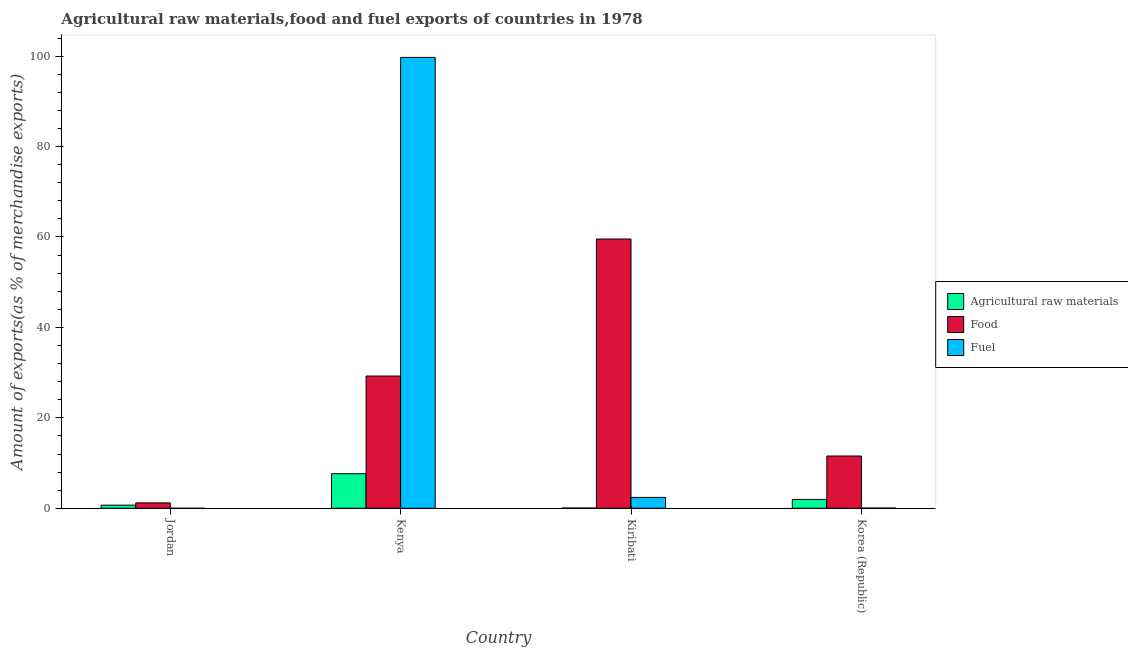How many different coloured bars are there?
Your answer should be very brief. 3. Are the number of bars on each tick of the X-axis equal?
Offer a very short reply. Yes. How many bars are there on the 3rd tick from the left?
Make the answer very short. 3. What is the label of the 2nd group of bars from the left?
Make the answer very short. Kenya. In how many cases, is the number of bars for a given country not equal to the number of legend labels?
Keep it short and to the point. 0. What is the percentage of raw materials exports in Jordan?
Make the answer very short. 0.69. Across all countries, what is the maximum percentage of food exports?
Your answer should be very brief. 59.55. Across all countries, what is the minimum percentage of fuel exports?
Your response must be concise. 0.01. In which country was the percentage of food exports maximum?
Keep it short and to the point. Kiribati. In which country was the percentage of food exports minimum?
Keep it short and to the point. Jordan. What is the total percentage of raw materials exports in the graph?
Make the answer very short. 10.35. What is the difference between the percentage of raw materials exports in Kenya and that in Kiribati?
Ensure brevity in your answer.  7.59. What is the difference between the percentage of food exports in Kenya and the percentage of raw materials exports in Korea (Republic)?
Keep it short and to the point. 27.29. What is the average percentage of raw materials exports per country?
Keep it short and to the point. 2.59. What is the difference between the percentage of fuel exports and percentage of food exports in Korea (Republic)?
Provide a succinct answer. -11.52. In how many countries, is the percentage of fuel exports greater than 36 %?
Provide a succinct answer. 1. What is the ratio of the percentage of fuel exports in Jordan to that in Kiribati?
Your answer should be compact. 0. What is the difference between the highest and the second highest percentage of food exports?
Provide a succinct answer. 30.3. What is the difference between the highest and the lowest percentage of food exports?
Offer a terse response. 58.36. In how many countries, is the percentage of food exports greater than the average percentage of food exports taken over all countries?
Provide a short and direct response. 2. What does the 2nd bar from the left in Kenya represents?
Provide a short and direct response. Food. What does the 1st bar from the right in Kenya represents?
Offer a terse response. Fuel. Is it the case that in every country, the sum of the percentage of raw materials exports and percentage of food exports is greater than the percentage of fuel exports?
Make the answer very short. No. How many bars are there?
Your response must be concise. 12. Are all the bars in the graph horizontal?
Offer a very short reply. No. How many countries are there in the graph?
Offer a terse response. 4. Are the values on the major ticks of Y-axis written in scientific E-notation?
Your answer should be compact. No. Does the graph contain grids?
Ensure brevity in your answer.  No. What is the title of the graph?
Provide a short and direct response. Agricultural raw materials,food and fuel exports of countries in 1978. What is the label or title of the X-axis?
Offer a very short reply. Country. What is the label or title of the Y-axis?
Provide a short and direct response. Amount of exports(as % of merchandise exports). What is the Amount of exports(as % of merchandise exports) of Agricultural raw materials in Jordan?
Give a very brief answer. 0.69. What is the Amount of exports(as % of merchandise exports) in Food in Jordan?
Make the answer very short. 1.2. What is the Amount of exports(as % of merchandise exports) of Fuel in Jordan?
Your answer should be compact. 0.01. What is the Amount of exports(as % of merchandise exports) in Agricultural raw materials in Kenya?
Keep it short and to the point. 7.65. What is the Amount of exports(as % of merchandise exports) in Food in Kenya?
Provide a succinct answer. 29.25. What is the Amount of exports(as % of merchandise exports) of Fuel in Kenya?
Your response must be concise. 99.72. What is the Amount of exports(as % of merchandise exports) in Agricultural raw materials in Kiribati?
Ensure brevity in your answer.  0.05. What is the Amount of exports(as % of merchandise exports) of Food in Kiribati?
Provide a succinct answer. 59.55. What is the Amount of exports(as % of merchandise exports) in Fuel in Kiribati?
Provide a succinct answer. 2.41. What is the Amount of exports(as % of merchandise exports) in Agricultural raw materials in Korea (Republic)?
Make the answer very short. 1.96. What is the Amount of exports(as % of merchandise exports) in Food in Korea (Republic)?
Provide a short and direct response. 11.56. What is the Amount of exports(as % of merchandise exports) of Fuel in Korea (Republic)?
Offer a very short reply. 0.04. Across all countries, what is the maximum Amount of exports(as % of merchandise exports) in Agricultural raw materials?
Offer a very short reply. 7.65. Across all countries, what is the maximum Amount of exports(as % of merchandise exports) in Food?
Your response must be concise. 59.55. Across all countries, what is the maximum Amount of exports(as % of merchandise exports) in Fuel?
Provide a short and direct response. 99.72. Across all countries, what is the minimum Amount of exports(as % of merchandise exports) of Agricultural raw materials?
Your answer should be very brief. 0.05. Across all countries, what is the minimum Amount of exports(as % of merchandise exports) in Food?
Keep it short and to the point. 1.2. Across all countries, what is the minimum Amount of exports(as % of merchandise exports) of Fuel?
Keep it short and to the point. 0.01. What is the total Amount of exports(as % of merchandise exports) in Agricultural raw materials in the graph?
Ensure brevity in your answer.  10.35. What is the total Amount of exports(as % of merchandise exports) in Food in the graph?
Give a very brief answer. 101.56. What is the total Amount of exports(as % of merchandise exports) of Fuel in the graph?
Keep it short and to the point. 102.18. What is the difference between the Amount of exports(as % of merchandise exports) in Agricultural raw materials in Jordan and that in Kenya?
Ensure brevity in your answer.  -6.96. What is the difference between the Amount of exports(as % of merchandise exports) in Food in Jordan and that in Kenya?
Keep it short and to the point. -28.05. What is the difference between the Amount of exports(as % of merchandise exports) of Fuel in Jordan and that in Kenya?
Give a very brief answer. -99.71. What is the difference between the Amount of exports(as % of merchandise exports) of Agricultural raw materials in Jordan and that in Kiribati?
Offer a very short reply. 0.64. What is the difference between the Amount of exports(as % of merchandise exports) of Food in Jordan and that in Kiribati?
Give a very brief answer. -58.36. What is the difference between the Amount of exports(as % of merchandise exports) in Fuel in Jordan and that in Kiribati?
Your answer should be very brief. -2.4. What is the difference between the Amount of exports(as % of merchandise exports) of Agricultural raw materials in Jordan and that in Korea (Republic)?
Keep it short and to the point. -1.27. What is the difference between the Amount of exports(as % of merchandise exports) in Food in Jordan and that in Korea (Republic)?
Your response must be concise. -10.36. What is the difference between the Amount of exports(as % of merchandise exports) of Fuel in Jordan and that in Korea (Republic)?
Offer a very short reply. -0.03. What is the difference between the Amount of exports(as % of merchandise exports) of Agricultural raw materials in Kenya and that in Kiribati?
Offer a very short reply. 7.59. What is the difference between the Amount of exports(as % of merchandise exports) in Food in Kenya and that in Kiribati?
Your answer should be compact. -30.3. What is the difference between the Amount of exports(as % of merchandise exports) of Fuel in Kenya and that in Kiribati?
Provide a succinct answer. 97.31. What is the difference between the Amount of exports(as % of merchandise exports) of Agricultural raw materials in Kenya and that in Korea (Republic)?
Offer a terse response. 5.69. What is the difference between the Amount of exports(as % of merchandise exports) in Food in Kenya and that in Korea (Republic)?
Your response must be concise. 17.69. What is the difference between the Amount of exports(as % of merchandise exports) in Fuel in Kenya and that in Korea (Republic)?
Your answer should be very brief. 99.68. What is the difference between the Amount of exports(as % of merchandise exports) of Agricultural raw materials in Kiribati and that in Korea (Republic)?
Your answer should be very brief. -1.91. What is the difference between the Amount of exports(as % of merchandise exports) of Food in Kiribati and that in Korea (Republic)?
Offer a terse response. 47.99. What is the difference between the Amount of exports(as % of merchandise exports) of Fuel in Kiribati and that in Korea (Republic)?
Give a very brief answer. 2.37. What is the difference between the Amount of exports(as % of merchandise exports) of Agricultural raw materials in Jordan and the Amount of exports(as % of merchandise exports) of Food in Kenya?
Your answer should be compact. -28.56. What is the difference between the Amount of exports(as % of merchandise exports) in Agricultural raw materials in Jordan and the Amount of exports(as % of merchandise exports) in Fuel in Kenya?
Your response must be concise. -99.03. What is the difference between the Amount of exports(as % of merchandise exports) in Food in Jordan and the Amount of exports(as % of merchandise exports) in Fuel in Kenya?
Keep it short and to the point. -98.52. What is the difference between the Amount of exports(as % of merchandise exports) in Agricultural raw materials in Jordan and the Amount of exports(as % of merchandise exports) in Food in Kiribati?
Make the answer very short. -58.86. What is the difference between the Amount of exports(as % of merchandise exports) of Agricultural raw materials in Jordan and the Amount of exports(as % of merchandise exports) of Fuel in Kiribati?
Keep it short and to the point. -1.72. What is the difference between the Amount of exports(as % of merchandise exports) of Food in Jordan and the Amount of exports(as % of merchandise exports) of Fuel in Kiribati?
Your answer should be very brief. -1.21. What is the difference between the Amount of exports(as % of merchandise exports) in Agricultural raw materials in Jordan and the Amount of exports(as % of merchandise exports) in Food in Korea (Republic)?
Provide a short and direct response. -10.87. What is the difference between the Amount of exports(as % of merchandise exports) of Agricultural raw materials in Jordan and the Amount of exports(as % of merchandise exports) of Fuel in Korea (Republic)?
Offer a terse response. 0.65. What is the difference between the Amount of exports(as % of merchandise exports) of Food in Jordan and the Amount of exports(as % of merchandise exports) of Fuel in Korea (Republic)?
Your answer should be compact. 1.16. What is the difference between the Amount of exports(as % of merchandise exports) of Agricultural raw materials in Kenya and the Amount of exports(as % of merchandise exports) of Food in Kiribati?
Ensure brevity in your answer.  -51.91. What is the difference between the Amount of exports(as % of merchandise exports) of Agricultural raw materials in Kenya and the Amount of exports(as % of merchandise exports) of Fuel in Kiribati?
Offer a terse response. 5.24. What is the difference between the Amount of exports(as % of merchandise exports) of Food in Kenya and the Amount of exports(as % of merchandise exports) of Fuel in Kiribati?
Your response must be concise. 26.84. What is the difference between the Amount of exports(as % of merchandise exports) of Agricultural raw materials in Kenya and the Amount of exports(as % of merchandise exports) of Food in Korea (Republic)?
Your answer should be very brief. -3.91. What is the difference between the Amount of exports(as % of merchandise exports) in Agricultural raw materials in Kenya and the Amount of exports(as % of merchandise exports) in Fuel in Korea (Republic)?
Make the answer very short. 7.6. What is the difference between the Amount of exports(as % of merchandise exports) of Food in Kenya and the Amount of exports(as % of merchandise exports) of Fuel in Korea (Republic)?
Provide a short and direct response. 29.21. What is the difference between the Amount of exports(as % of merchandise exports) in Agricultural raw materials in Kiribati and the Amount of exports(as % of merchandise exports) in Food in Korea (Republic)?
Offer a terse response. -11.51. What is the difference between the Amount of exports(as % of merchandise exports) in Agricultural raw materials in Kiribati and the Amount of exports(as % of merchandise exports) in Fuel in Korea (Republic)?
Offer a terse response. 0.01. What is the difference between the Amount of exports(as % of merchandise exports) in Food in Kiribati and the Amount of exports(as % of merchandise exports) in Fuel in Korea (Republic)?
Provide a short and direct response. 59.51. What is the average Amount of exports(as % of merchandise exports) in Agricultural raw materials per country?
Your response must be concise. 2.59. What is the average Amount of exports(as % of merchandise exports) of Food per country?
Provide a succinct answer. 25.39. What is the average Amount of exports(as % of merchandise exports) of Fuel per country?
Your answer should be compact. 25.54. What is the difference between the Amount of exports(as % of merchandise exports) of Agricultural raw materials and Amount of exports(as % of merchandise exports) of Food in Jordan?
Offer a very short reply. -0.51. What is the difference between the Amount of exports(as % of merchandise exports) of Agricultural raw materials and Amount of exports(as % of merchandise exports) of Fuel in Jordan?
Provide a succinct answer. 0.68. What is the difference between the Amount of exports(as % of merchandise exports) of Food and Amount of exports(as % of merchandise exports) of Fuel in Jordan?
Your response must be concise. 1.19. What is the difference between the Amount of exports(as % of merchandise exports) in Agricultural raw materials and Amount of exports(as % of merchandise exports) in Food in Kenya?
Ensure brevity in your answer.  -21.6. What is the difference between the Amount of exports(as % of merchandise exports) of Agricultural raw materials and Amount of exports(as % of merchandise exports) of Fuel in Kenya?
Ensure brevity in your answer.  -92.07. What is the difference between the Amount of exports(as % of merchandise exports) of Food and Amount of exports(as % of merchandise exports) of Fuel in Kenya?
Give a very brief answer. -70.47. What is the difference between the Amount of exports(as % of merchandise exports) in Agricultural raw materials and Amount of exports(as % of merchandise exports) in Food in Kiribati?
Provide a succinct answer. -59.5. What is the difference between the Amount of exports(as % of merchandise exports) in Agricultural raw materials and Amount of exports(as % of merchandise exports) in Fuel in Kiribati?
Your response must be concise. -2.36. What is the difference between the Amount of exports(as % of merchandise exports) of Food and Amount of exports(as % of merchandise exports) of Fuel in Kiribati?
Make the answer very short. 57.14. What is the difference between the Amount of exports(as % of merchandise exports) of Agricultural raw materials and Amount of exports(as % of merchandise exports) of Food in Korea (Republic)?
Your response must be concise. -9.6. What is the difference between the Amount of exports(as % of merchandise exports) of Agricultural raw materials and Amount of exports(as % of merchandise exports) of Fuel in Korea (Republic)?
Make the answer very short. 1.92. What is the difference between the Amount of exports(as % of merchandise exports) in Food and Amount of exports(as % of merchandise exports) in Fuel in Korea (Republic)?
Your response must be concise. 11.52. What is the ratio of the Amount of exports(as % of merchandise exports) in Agricultural raw materials in Jordan to that in Kenya?
Offer a very short reply. 0.09. What is the ratio of the Amount of exports(as % of merchandise exports) in Food in Jordan to that in Kenya?
Make the answer very short. 0.04. What is the ratio of the Amount of exports(as % of merchandise exports) of Fuel in Jordan to that in Kenya?
Give a very brief answer. 0. What is the ratio of the Amount of exports(as % of merchandise exports) of Agricultural raw materials in Jordan to that in Kiribati?
Offer a very short reply. 12.98. What is the ratio of the Amount of exports(as % of merchandise exports) of Food in Jordan to that in Kiribati?
Your response must be concise. 0.02. What is the ratio of the Amount of exports(as % of merchandise exports) of Fuel in Jordan to that in Kiribati?
Your answer should be compact. 0. What is the ratio of the Amount of exports(as % of merchandise exports) in Agricultural raw materials in Jordan to that in Korea (Republic)?
Offer a very short reply. 0.35. What is the ratio of the Amount of exports(as % of merchandise exports) of Food in Jordan to that in Korea (Republic)?
Keep it short and to the point. 0.1. What is the ratio of the Amount of exports(as % of merchandise exports) in Fuel in Jordan to that in Korea (Republic)?
Provide a succinct answer. 0.16. What is the ratio of the Amount of exports(as % of merchandise exports) of Agricultural raw materials in Kenya to that in Kiribati?
Your answer should be very brief. 144.19. What is the ratio of the Amount of exports(as % of merchandise exports) in Food in Kenya to that in Kiribati?
Your response must be concise. 0.49. What is the ratio of the Amount of exports(as % of merchandise exports) of Fuel in Kenya to that in Kiribati?
Offer a terse response. 41.39. What is the ratio of the Amount of exports(as % of merchandise exports) in Food in Kenya to that in Korea (Republic)?
Provide a short and direct response. 2.53. What is the ratio of the Amount of exports(as % of merchandise exports) in Fuel in Kenya to that in Korea (Republic)?
Your answer should be compact. 2410.18. What is the ratio of the Amount of exports(as % of merchandise exports) of Agricultural raw materials in Kiribati to that in Korea (Republic)?
Ensure brevity in your answer.  0.03. What is the ratio of the Amount of exports(as % of merchandise exports) of Food in Kiribati to that in Korea (Republic)?
Provide a short and direct response. 5.15. What is the ratio of the Amount of exports(as % of merchandise exports) of Fuel in Kiribati to that in Korea (Republic)?
Provide a short and direct response. 58.23. What is the difference between the highest and the second highest Amount of exports(as % of merchandise exports) in Agricultural raw materials?
Give a very brief answer. 5.69. What is the difference between the highest and the second highest Amount of exports(as % of merchandise exports) in Food?
Your response must be concise. 30.3. What is the difference between the highest and the second highest Amount of exports(as % of merchandise exports) in Fuel?
Ensure brevity in your answer.  97.31. What is the difference between the highest and the lowest Amount of exports(as % of merchandise exports) in Agricultural raw materials?
Make the answer very short. 7.59. What is the difference between the highest and the lowest Amount of exports(as % of merchandise exports) of Food?
Keep it short and to the point. 58.36. What is the difference between the highest and the lowest Amount of exports(as % of merchandise exports) of Fuel?
Provide a short and direct response. 99.71. 